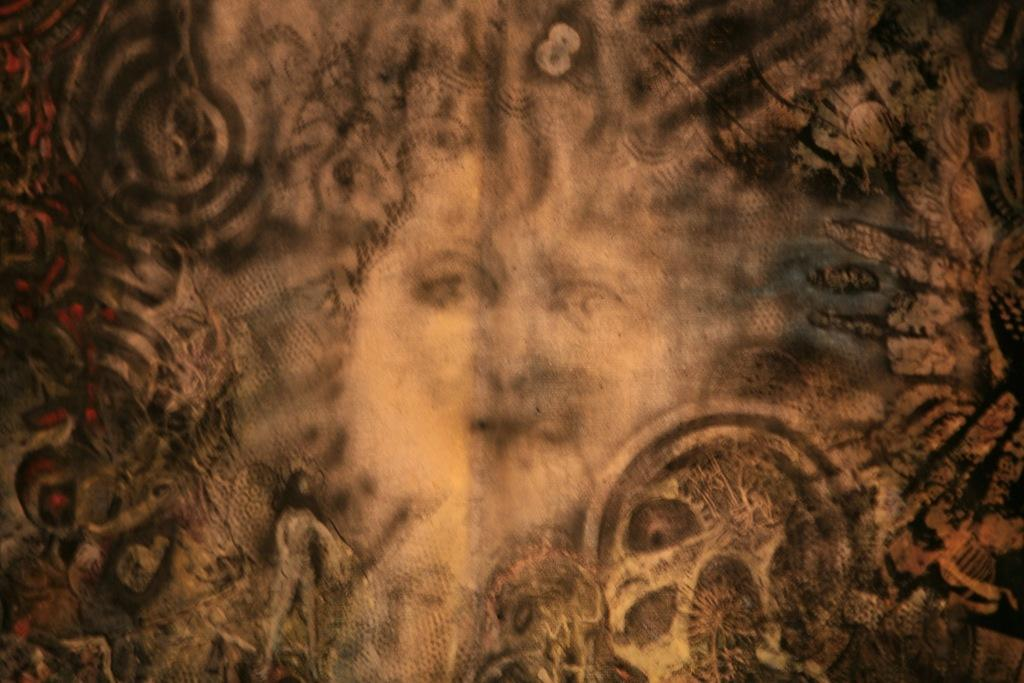What type of artwork is depicted in the image? The image is a wall painting. What is the main subject of the painting? There is a face of a person in the painting. Can you describe any other characters or elements in the painting? There is a man in the painting, and there are many structures present. What type of leather is used to create the birds in the painting? There are no birds present in the painting, so the type of leather used cannot be determined. 